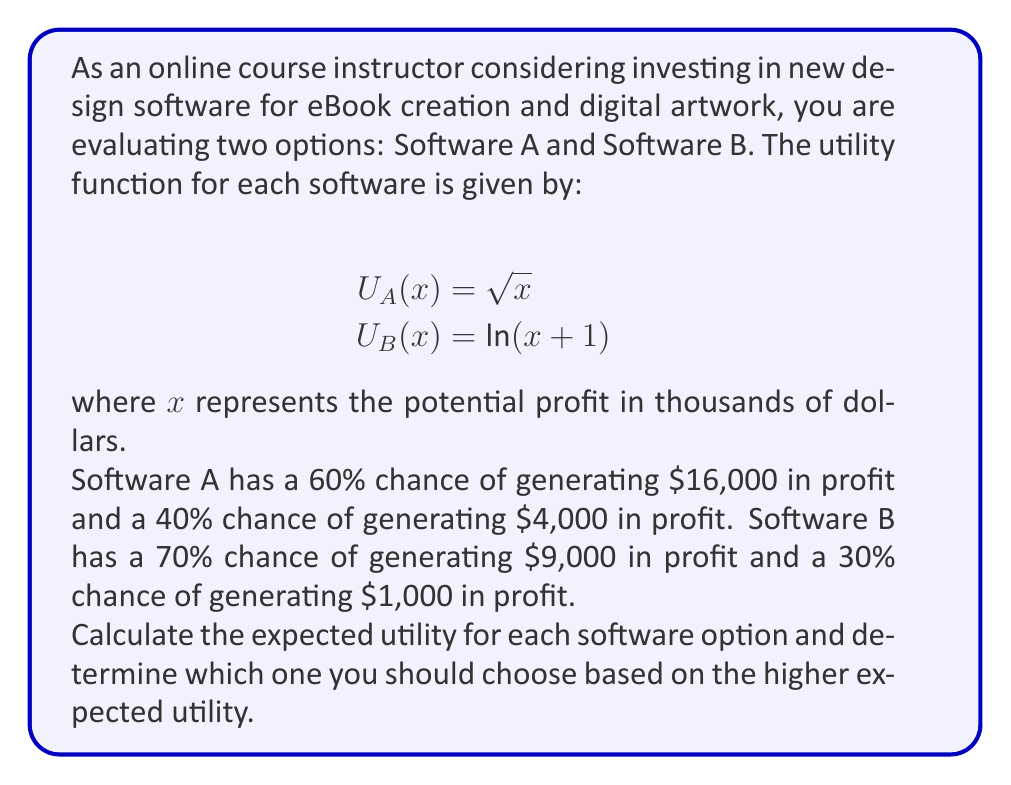Give your solution to this math problem. To solve this problem, we need to follow these steps:

1. Calculate the utility values for each possible outcome using the given utility functions.
2. Calculate the expected utility for each software option.
3. Compare the expected utilities to make a decision.

Step 1: Calculate utility values

For Software A:
$U_A(16) = \sqrt{16} = 4$
$U_A(4) = \sqrt{4} = 2$

For Software B:
$U_B(9) = \ln(9+1) = \ln(10) \approx 2.30$
$U_B(1) = \ln(1+1) = \ln(2) \approx 0.69$

Step 2: Calculate expected utilities

The expected utility is calculated by multiplying each utility value by its probability and summing the results.

For Software A:
$$E[U_A] = 0.60 \cdot U_A(16) + 0.40 \cdot U_A(4)$$
$$E[U_A] = 0.60 \cdot 4 + 0.40 \cdot 2 = 2.40 + 0.80 = 3.20$$

For Software B:
$$E[U_B] = 0.70 \cdot U_B(9) + 0.30 \cdot U_B(1)$$
$$E[U_B] = 0.70 \cdot 2.30 + 0.30 \cdot 0.69 = 1.61 + 0.21 = 1.82$$

Step 3: Compare expected utilities

The expected utility of Software A (3.20) is higher than the expected utility of Software B (1.82).
Answer: Based on the higher expected utility, you should choose Software A with an expected utility of 3.20. 